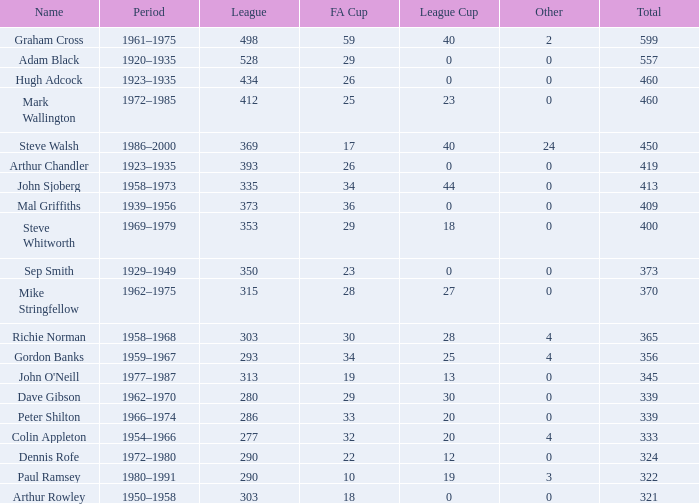What is the average number of FA cups Steve Whitworth, who has less than 400 total, has? None. 